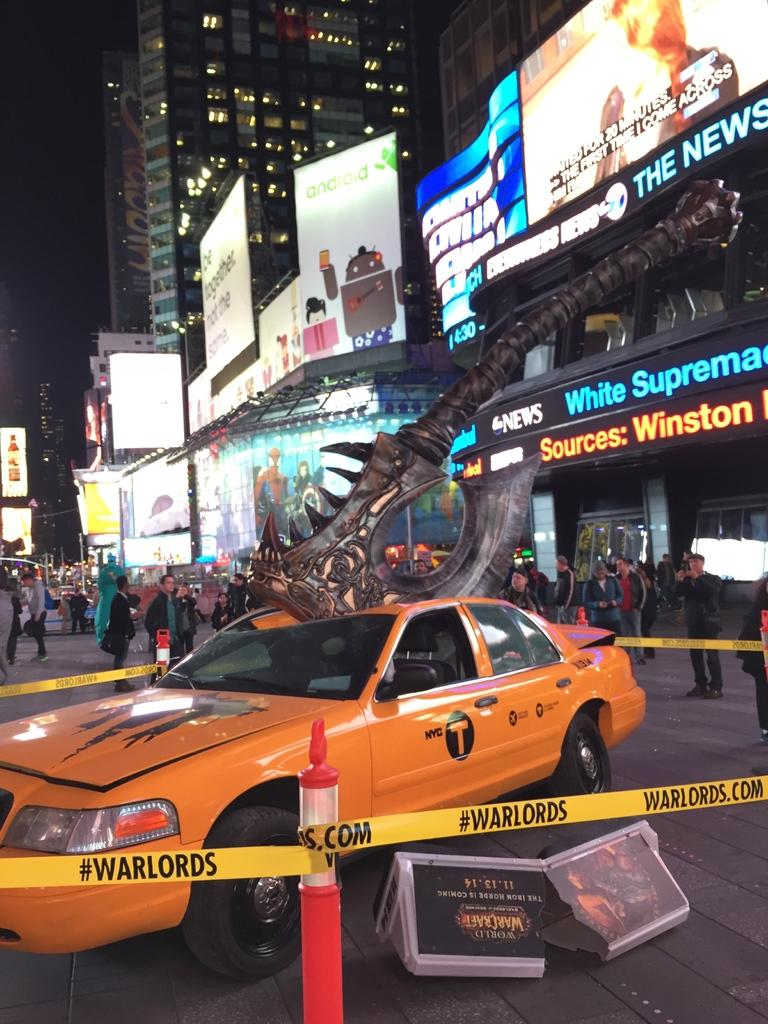<image>
Describe the image concisely. The caution tape around the taxi says #WARLORDS on it. 